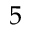Convert formula to latex. <formula><loc_0><loc_0><loc_500><loc_500>5</formula> 